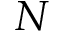<formula> <loc_0><loc_0><loc_500><loc_500>N</formula> 